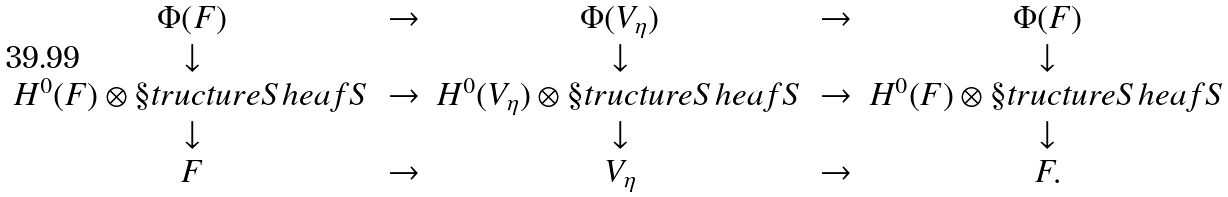<formula> <loc_0><loc_0><loc_500><loc_500>\begin{array} { c c c c c } \Phi ( F ) & \rightarrow & \Phi ( V _ { \eta } ) & \rightarrow & \Phi ( F ) \\ \downarrow & & \downarrow & & \downarrow \\ H ^ { 0 } ( F ) \otimes \S t r u c t u r e S h e a f { S } & \rightarrow & H ^ { 0 } ( V _ { \eta } ) \otimes \S t r u c t u r e S h e a f { S } & \rightarrow & H ^ { 0 } ( F ) \otimes \S t r u c t u r e S h e a f { S } \\ \downarrow & & \downarrow & & \downarrow \\ F & \rightarrow & V _ { \eta } & \rightarrow & F . \end{array}</formula> 